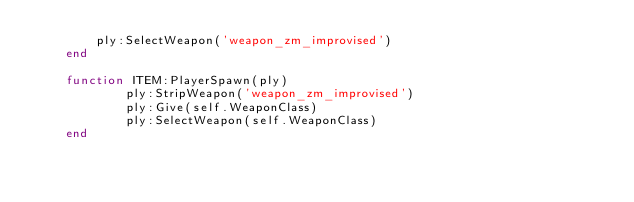Convert code to text. <code><loc_0><loc_0><loc_500><loc_500><_Lua_>		ply:SelectWeapon('weapon_zm_improvised')
	end
	
	function ITEM:PlayerSpawn(ply)
			ply:StripWeapon('weapon_zm_improvised')
			ply:Give(self.WeaponClass)
			ply:SelectWeapon(self.WeaponClass)
	end</code> 